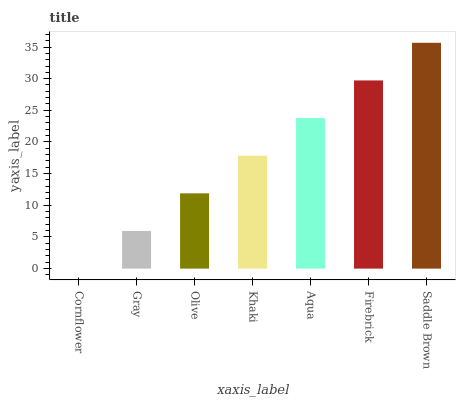Is Cornflower the minimum?
Answer yes or no. Yes. Is Saddle Brown the maximum?
Answer yes or no. Yes. Is Gray the minimum?
Answer yes or no. No. Is Gray the maximum?
Answer yes or no. No. Is Gray greater than Cornflower?
Answer yes or no. Yes. Is Cornflower less than Gray?
Answer yes or no. Yes. Is Cornflower greater than Gray?
Answer yes or no. No. Is Gray less than Cornflower?
Answer yes or no. No. Is Khaki the high median?
Answer yes or no. Yes. Is Khaki the low median?
Answer yes or no. Yes. Is Firebrick the high median?
Answer yes or no. No. Is Gray the low median?
Answer yes or no. No. 